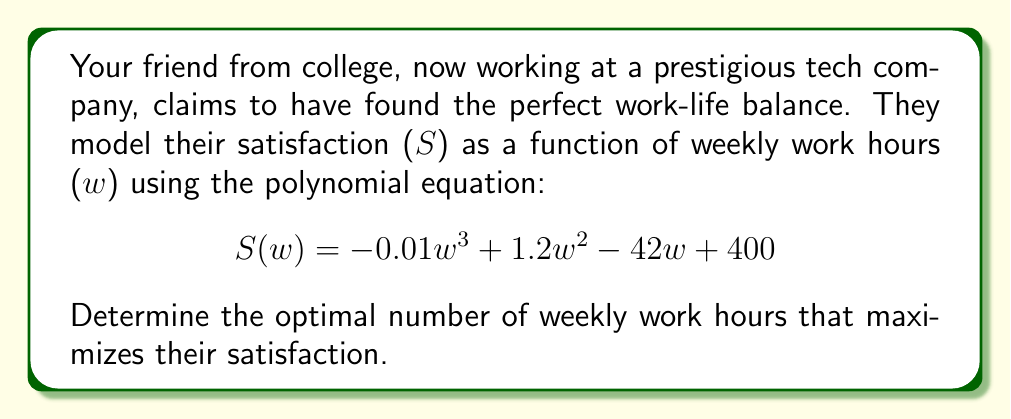Provide a solution to this math problem. To find the optimal number of work hours that maximizes satisfaction, we need to find the maximum point of the given polynomial function. This can be done by following these steps:

1. Find the derivative of $S(w)$:
   $S'(w) = -0.03w^2 + 2.4w - 42$

2. Set the derivative equal to zero to find critical points:
   $-0.03w^2 + 2.4w - 42 = 0$

3. Solve the quadratic equation:
   $a = -0.03$, $b = 2.4$, $c = -42$
   Use the quadratic formula: $w = \frac{-b \pm \sqrt{b^2 - 4ac}}{2a}$

   $w = \frac{-2.4 \pm \sqrt{2.4^2 - 4(-0.03)(-42)}}{2(-0.03)}$
   $w = \frac{-2.4 \pm \sqrt{5.76 - 5.04}}{-0.06}$
   $w = \frac{-2.4 \pm \sqrt{0.72}}{-0.06}$
   $w = \frac{-2.4 \pm 0.8485}{-0.06}$

4. This gives us two solutions:
   $w_1 = \frac{-2.4 + 0.8485}{-0.06} \approx 25.86$
   $w_2 = \frac{-2.4 - 0.8485}{-0.06} \approx 54.14$

5. To determine which solution gives the maximum, we can check the second derivative:
   $S''(w) = -0.06w + 2.4$
   At $w = 25.86$: $S''(25.86) = -1.55 < 0$ (maximum)
   At $w = 54.14$: $S''(54.14) = 0.85 > 0$ (minimum)

Therefore, the optimal number of weekly work hours that maximizes satisfaction is approximately 25.86 hours.
Answer: 25.86 hours 